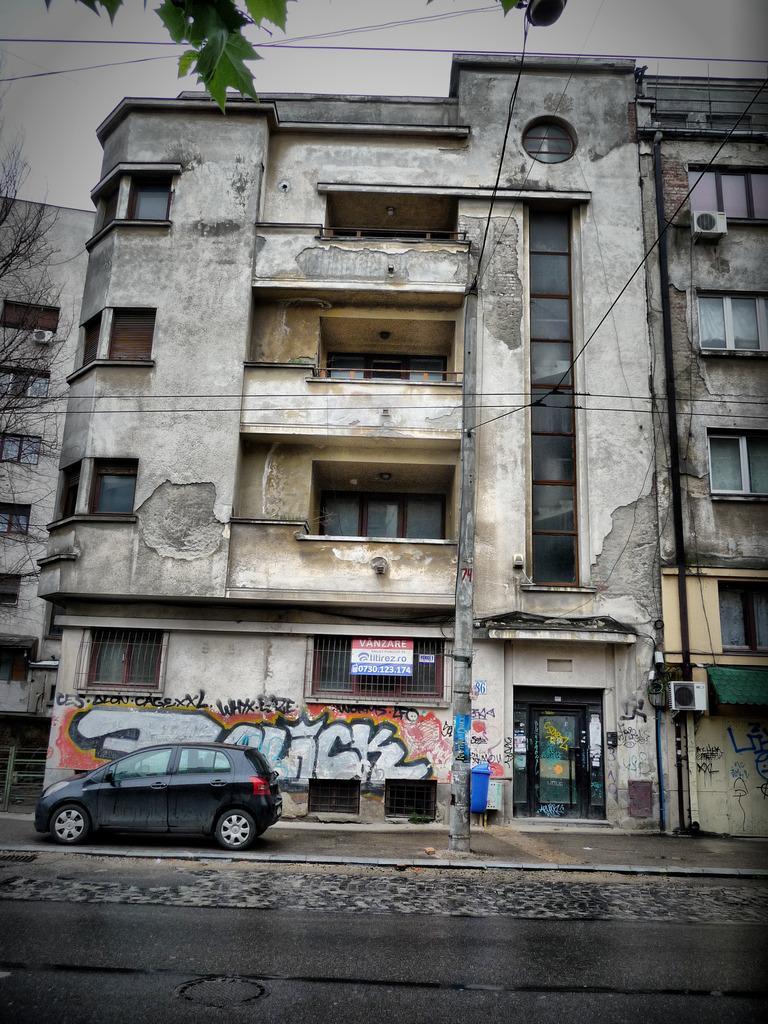Could you give a brief overview of what you see in this image? In this image there is a building in the middle. At the bottom there is a road. There is a car parked on the footpath. Beside the car there is a wall on which there is some graphite. In the middle there is a pole to which there are wires. There is a board attached to the building. At the top there are leaves. 